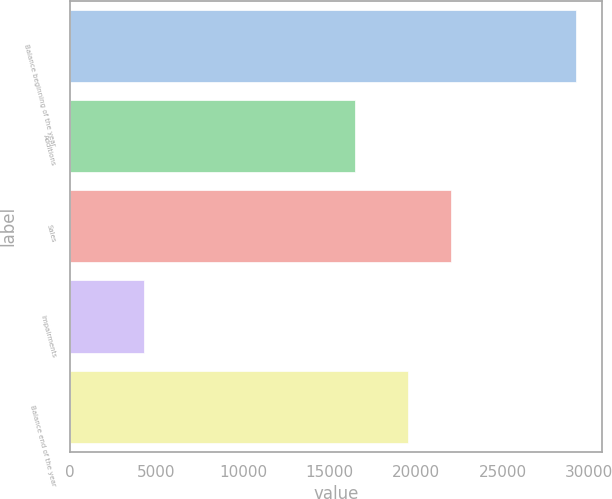Convert chart. <chart><loc_0><loc_0><loc_500><loc_500><bar_chart><fcel>Balance beginning of the year<fcel>Additions<fcel>Sales<fcel>Impairments<fcel>Balance end of the year<nl><fcel>29252<fcel>16463<fcel>22027.8<fcel>4294<fcel>19532<nl></chart> 